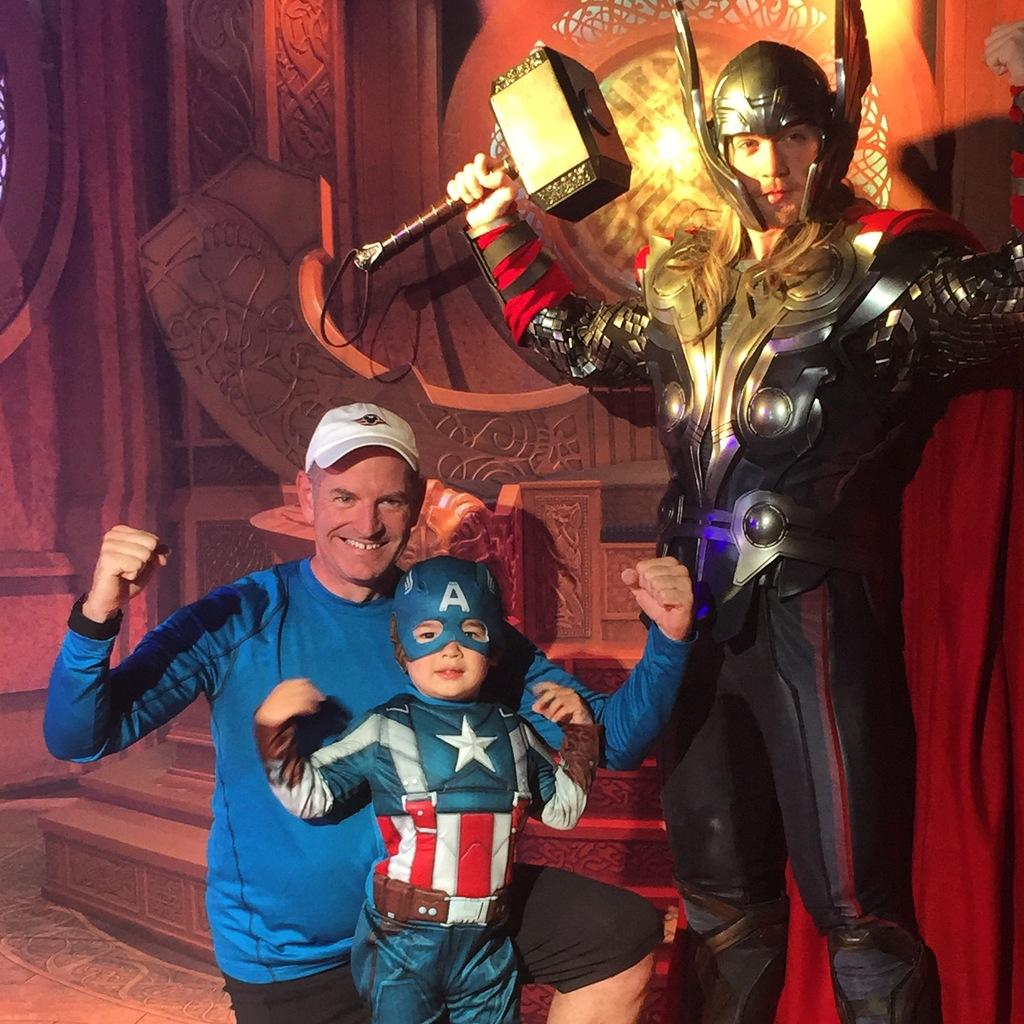Who or what can be seen in the image? There are people in the image. What are the people wearing in the image? The people are wearing costumes of the Avengers. Can you describe any specific details about the costumes? One person is holding a hammer in their hand, which suggests they are dressed as Thor. What type of pin can be seen holding the coal together in the image? There is no pin or coal present in the image. What class are the people attending in the image? The image does not show any indication of a class or educational setting. 